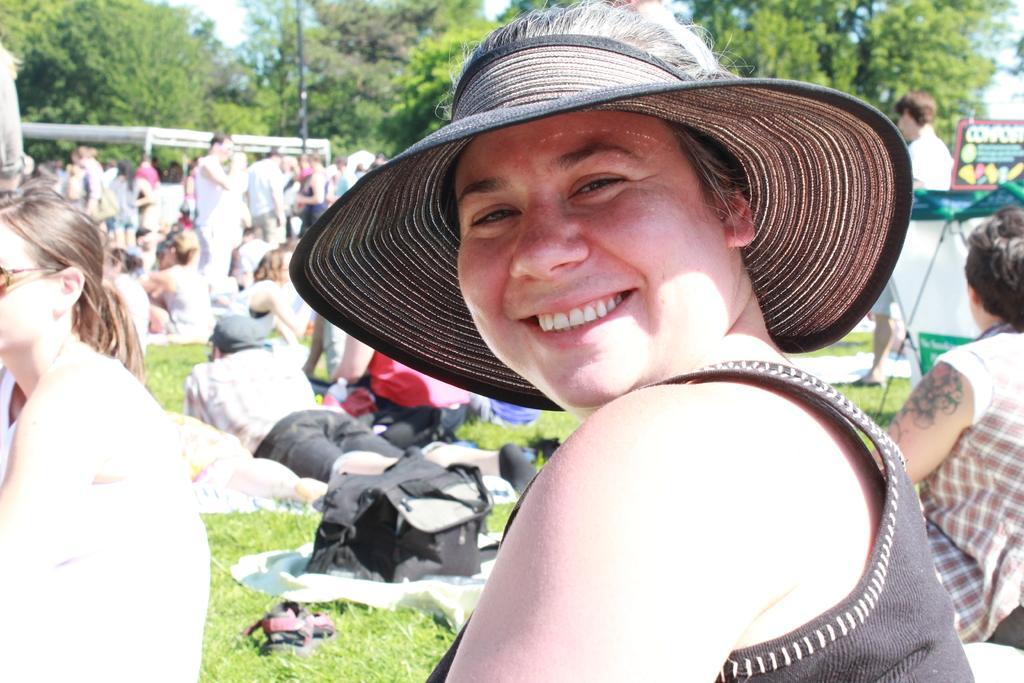In one or two sentences, can you explain what this image depicts? In this image, there are a few people, trees. We can see the ground with some objects. We can also see some grass, a pole and a few posts. We can also see the sky. 